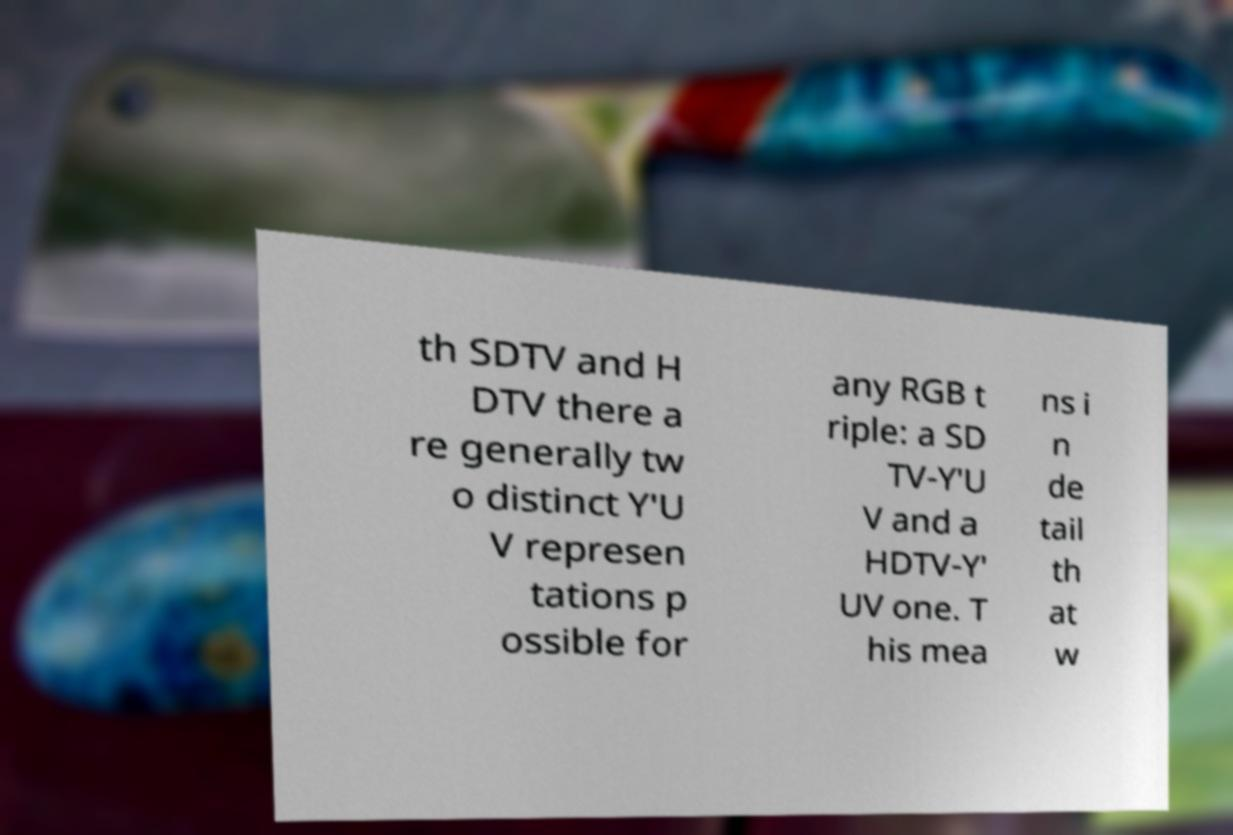Could you extract and type out the text from this image? th SDTV and H DTV there a re generally tw o distinct Y′U V represen tations p ossible for any RGB t riple: a SD TV-Y′U V and a HDTV-Y′ UV one. T his mea ns i n de tail th at w 